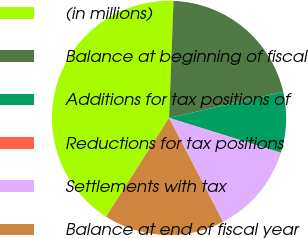Convert chart. <chart><loc_0><loc_0><loc_500><loc_500><pie_chart><fcel>(in millions)<fcel>Balance at beginning of fiscal<fcel>Additions for tax positions of<fcel>Reductions for tax positions<fcel>Settlements with tax<fcel>Balance at end of fiscal year<nl><fcel>41.57%<fcel>20.82%<fcel>8.36%<fcel>0.06%<fcel>12.52%<fcel>16.67%<nl></chart> 